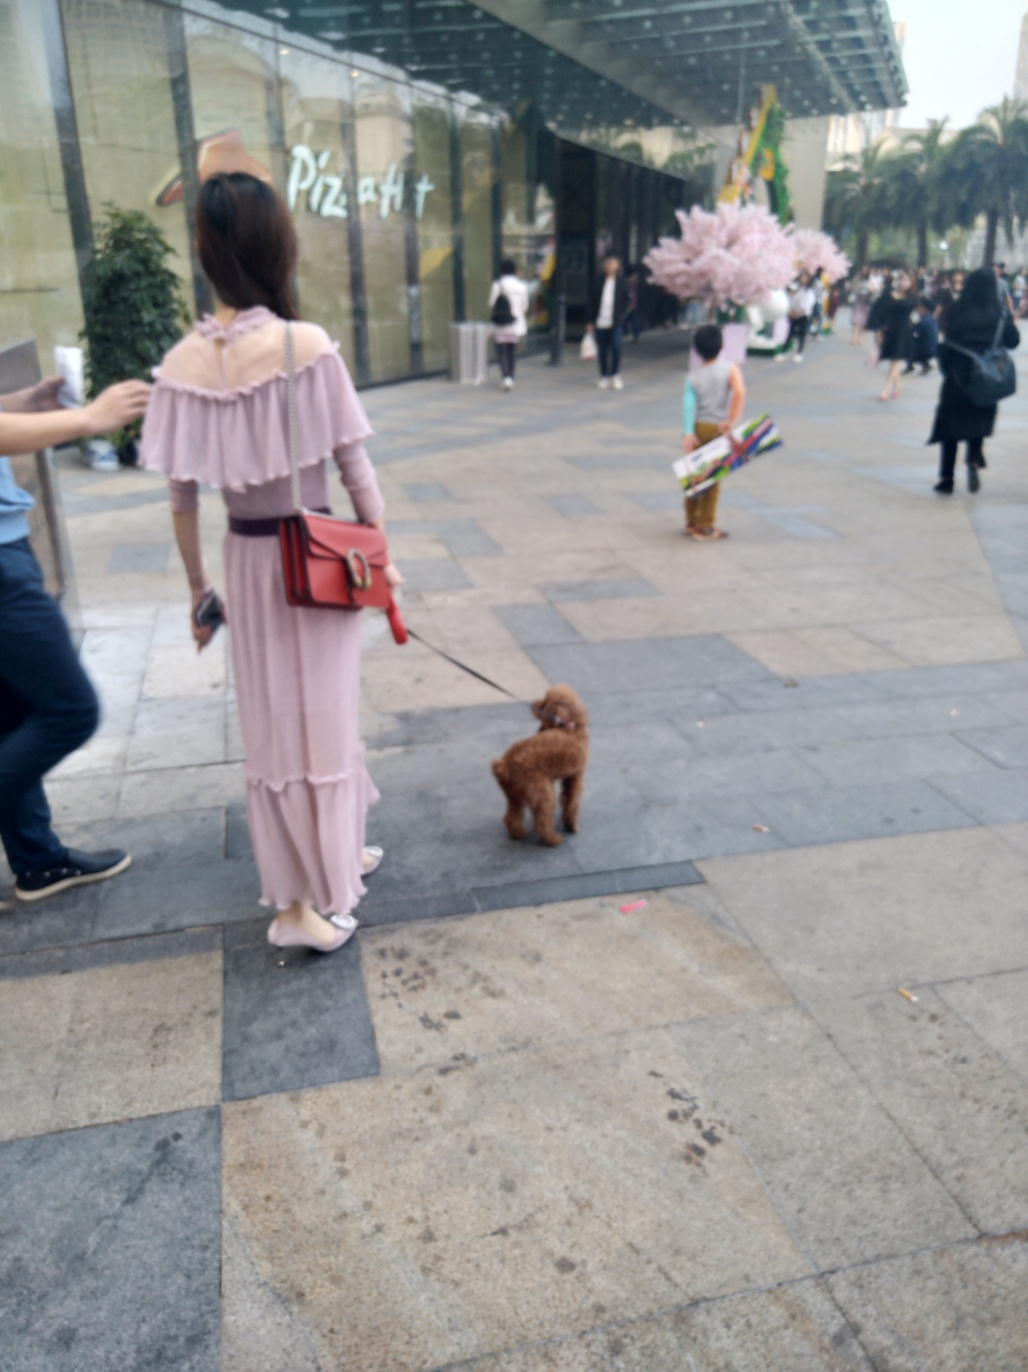How would you describe the lighting in this image?
A. Adequate lighting
B. Dim lighting
C. Bright lighting
D. Harsh lighting
Answer with the option's letter from the given choices directly. The lighting in the image appears to be adequate; it is neither too dim nor too bright. There are no harsh shadows or overexposed areas that would suggest harsh lighting, and visibility is clear enough to observe details without strain, which eliminates the potential for dim lighting. Therefore, the most accurate description of the lighting in this image would be option A, adequate lighting. 